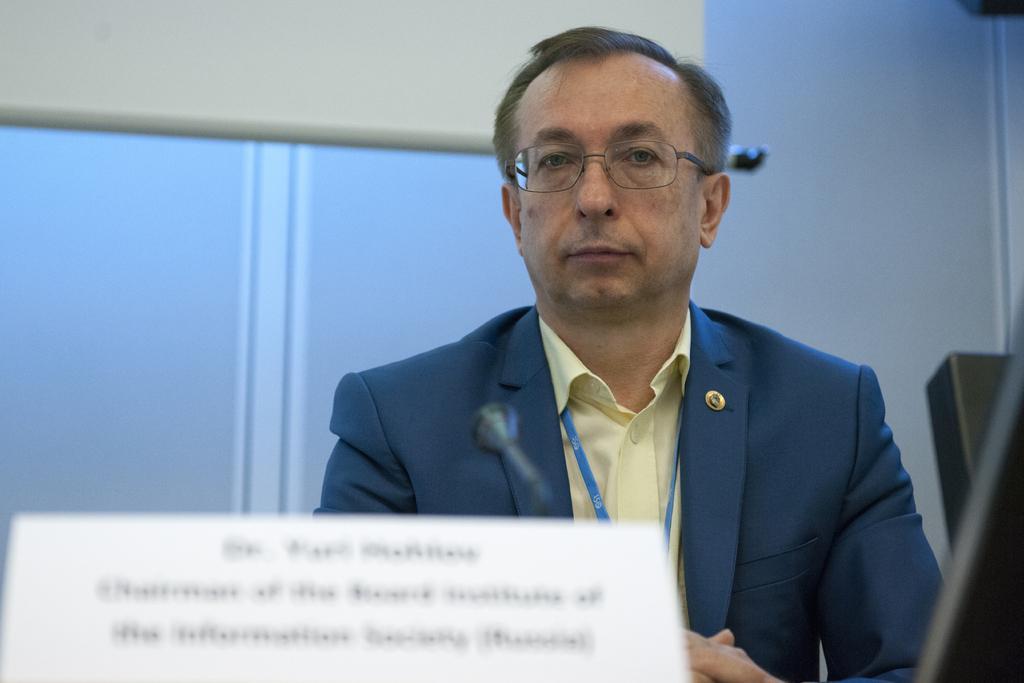Can you describe this image briefly? In the image we can see there is a man and he is wearing formal suit. There is mic kept on the stand and there is name plate kept on the table. In front the image is little blurred. 